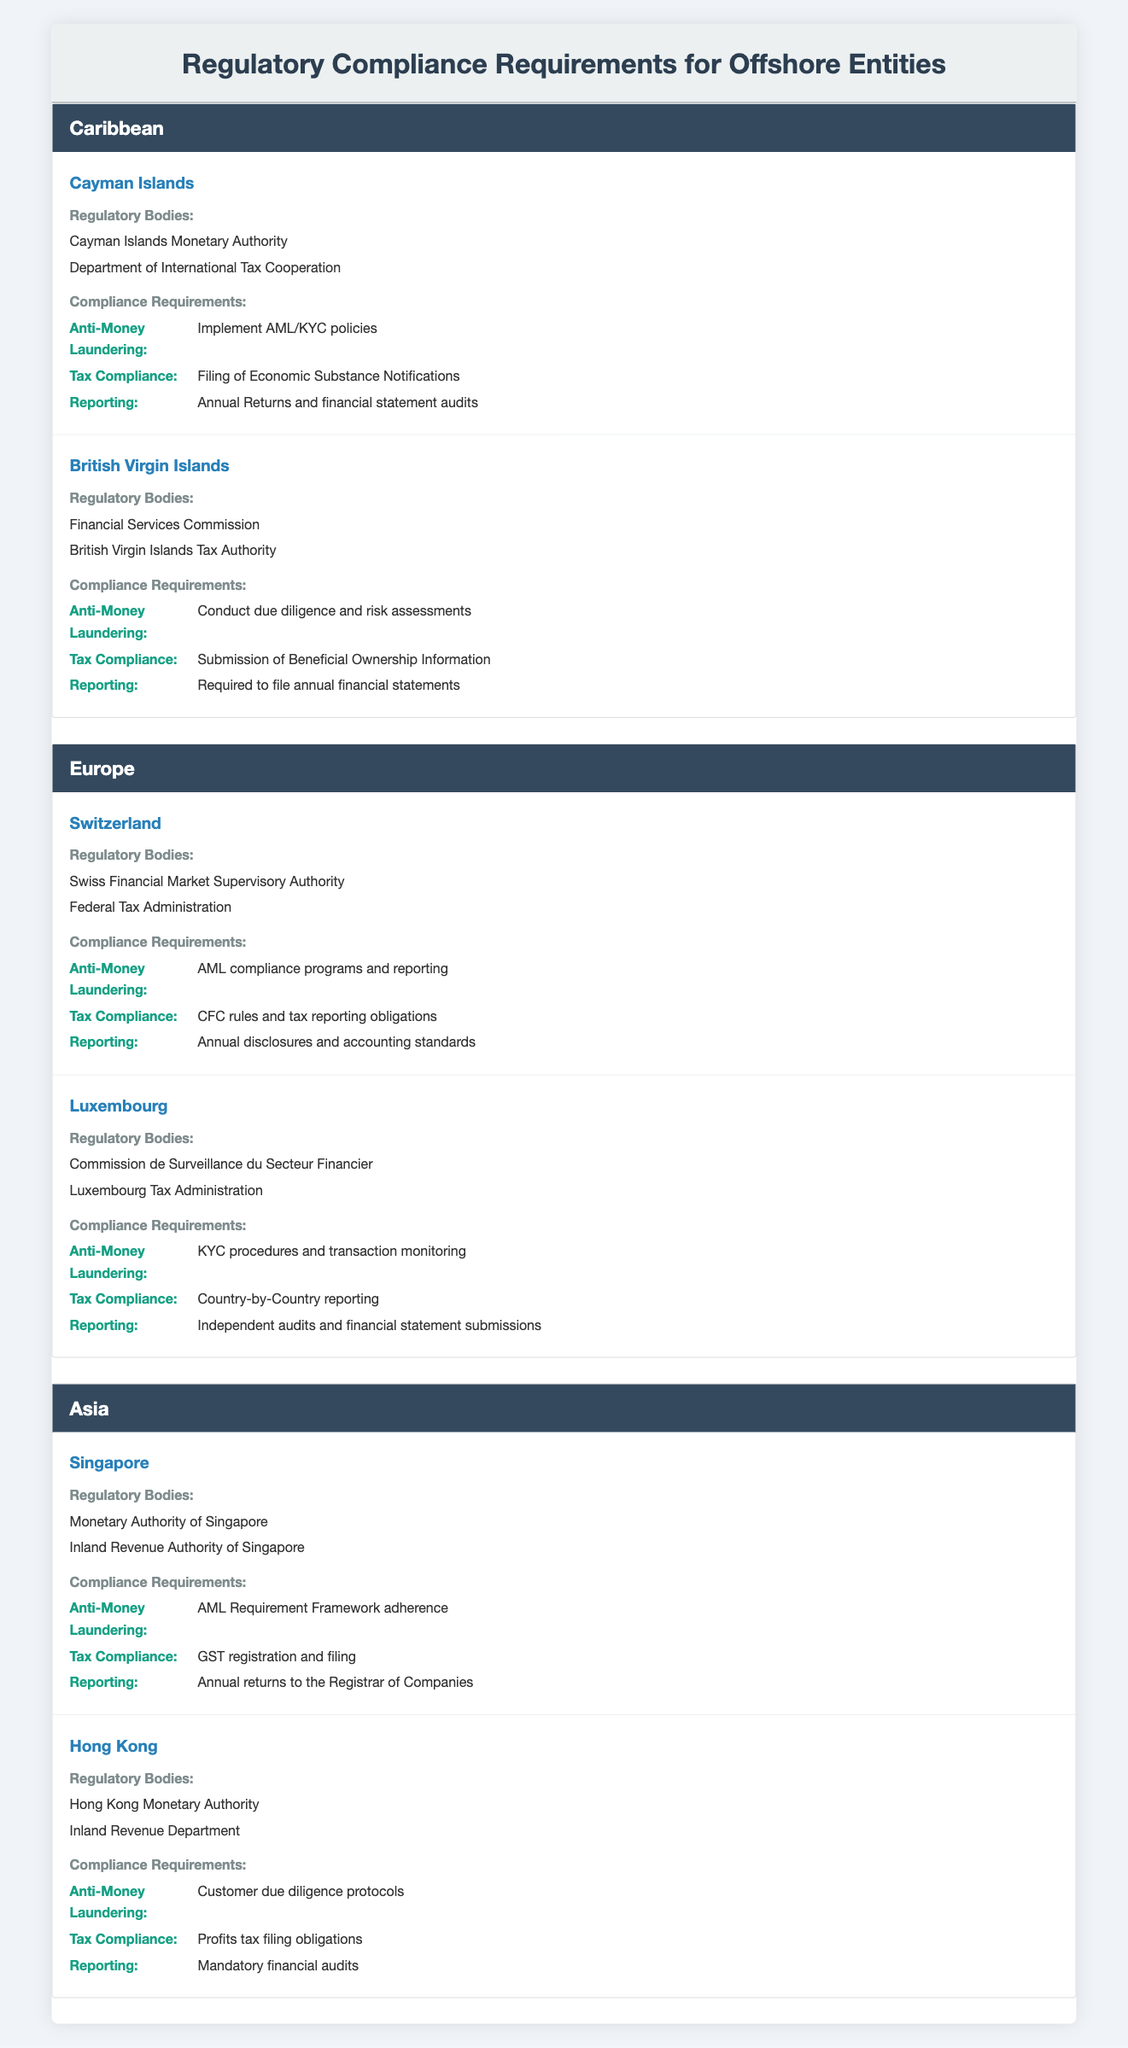What are the regulatory bodies for the Cayman Islands? The table lists two regulatory bodies for the Cayman Islands: the Cayman Islands Monetary Authority and the Department of International Tax Cooperation.
Answer: Cayman Islands Monetary Authority, Department of International Tax Cooperation Which country requires the filing of Beneficial Ownership Information? According to the table, the British Virgin Islands require the submission of Beneficial Ownership Information as part of their tax compliance requirements.
Answer: British Virgin Islands Does Singapore have a requirement for GST registration? The compliance requirements for Singapore state that there is a tax compliance obligation for GST registration and filing, confirming that they do indeed have this requirement.
Answer: Yes How many regulatory bodies are listed for Luxembourg? The table shows that Luxembourg has two regulatory bodies: the Commission de Surveillance du Secteur Financier and the Luxembourg Tax Administration.
Answer: 2 Which region has the most countries mentioned? The Caribbean and Europe regions each contain two countries, while Asia also contains two countries; hence, there's no single region with more countries than the others.
Answer: No region has more countries than others; all have 2 What is the average number of compliance requirements across all listed countries? The countries listed have compliance requirements as follows: Cayman Islands (3), British Virgin Islands (3), Switzerland (3), Luxembourg (3), Singapore (3), and Hong Kong (3). Thus, the total number is 18, and with 6 countries, the average is 18/6 = 3.
Answer: 3 Do all countries mentioned have a reporting requirement? The table indicates that all listed countries have specific reporting requirements outlined, confirming that this is a common requirement among them.
Answer: Yes What unique requirement does Hong Kong have compared to Singapore? While both countries have anti-money laundering requirements, Hong Kong specifically has customer due diligence protocols, while Singapore requires adherence to an AML Requirement Framework. This indicates Hong Kong has a unique focus on customer due diligence.
Answer: Customer due diligence protocols What is the tax compliance requirement for the Cayman Islands? The table states that the Cayman Islands require the filing of Economic Substance Notifications for tax compliance, clearly indicating this specific obligation.
Answer: Filing of Economic Substance Notifications 